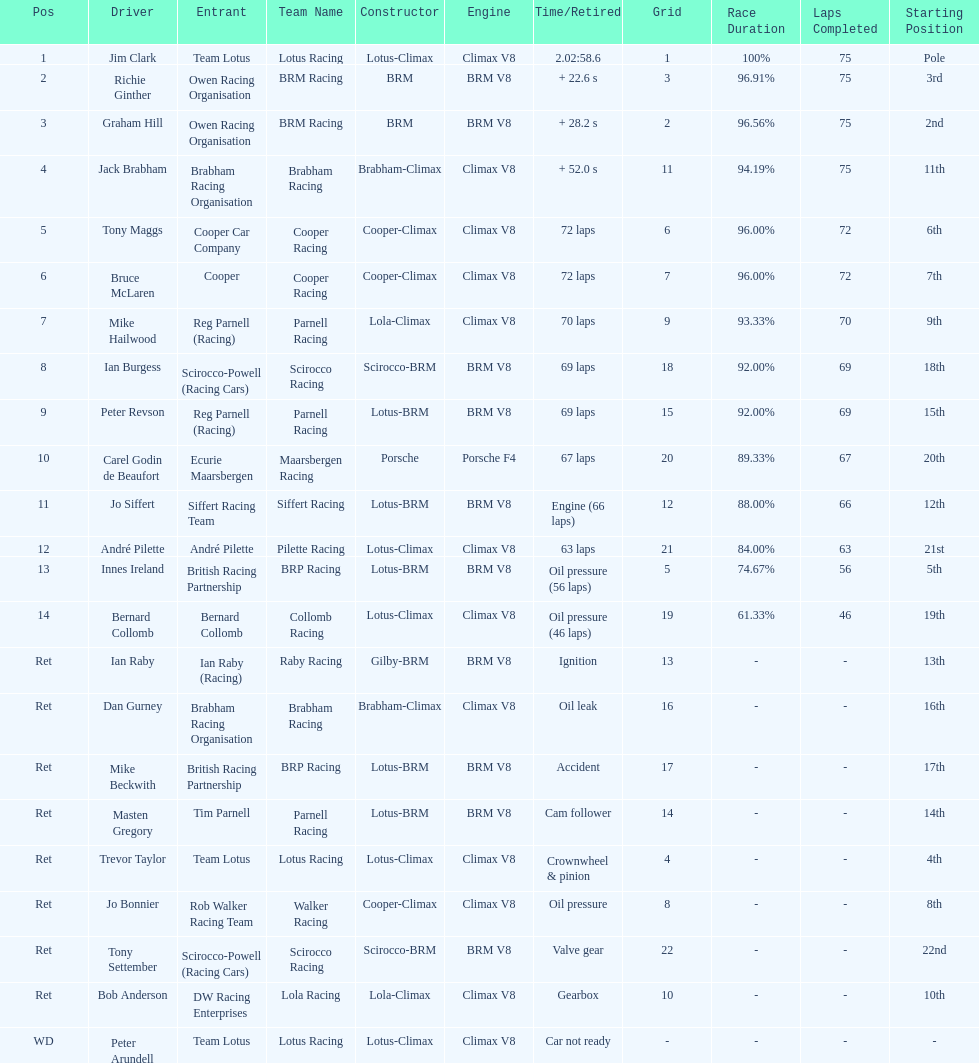Who was the top finisher that drove a cooper-climax? Tony Maggs. 